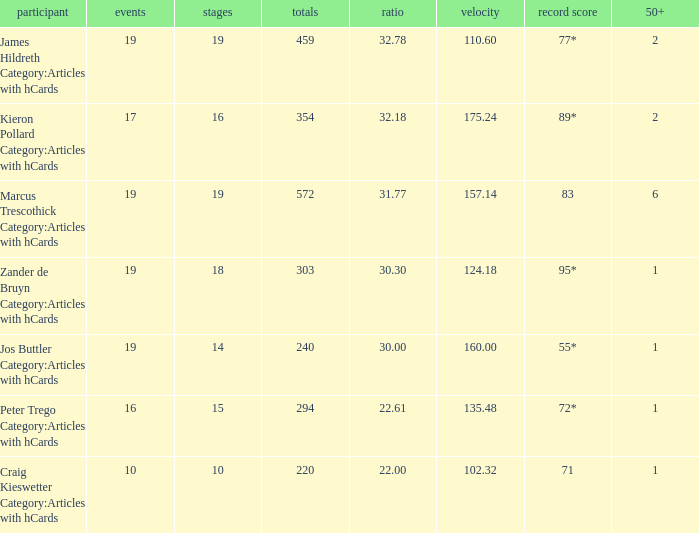Can you parse all the data within this table? {'header': ['participant', 'events', 'stages', 'totals', 'ratio', 'velocity', 'record score', '50+'], 'rows': [['James Hildreth Category:Articles with hCards', '19', '19', '459', '32.78', '110.60', '77*', '2'], ['Kieron Pollard Category:Articles with hCards', '17', '16', '354', '32.18', '175.24', '89*', '2'], ['Marcus Trescothick Category:Articles with hCards', '19', '19', '572', '31.77', '157.14', '83', '6'], ['Zander de Bruyn Category:Articles with hCards', '19', '18', '303', '30.30', '124.18', '95*', '1'], ['Jos Buttler Category:Articles with hCards', '19', '14', '240', '30.00', '160.00', '55*', '1'], ['Peter Trego Category:Articles with hCards', '16', '15', '294', '22.61', '135.48', '72*', '1'], ['Craig Kieswetter Category:Articles with hCards', '10', '10', '220', '22.00', '102.32', '71', '1']]} What is the strike rate for the player with an average of 32.78? 110.6. 